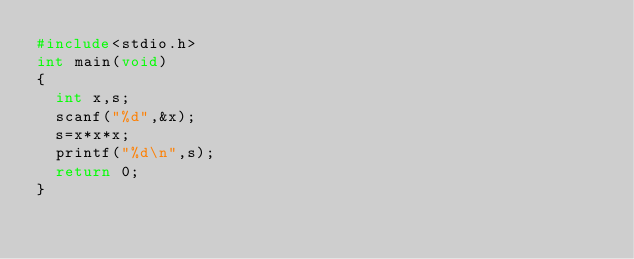<code> <loc_0><loc_0><loc_500><loc_500><_C_>#include<stdio.h>
int main(void)
{
	int x,s;
	scanf("%d",&x);
	s=x*x*x;
	printf("%d\n",s);
	return 0;
}</code> 